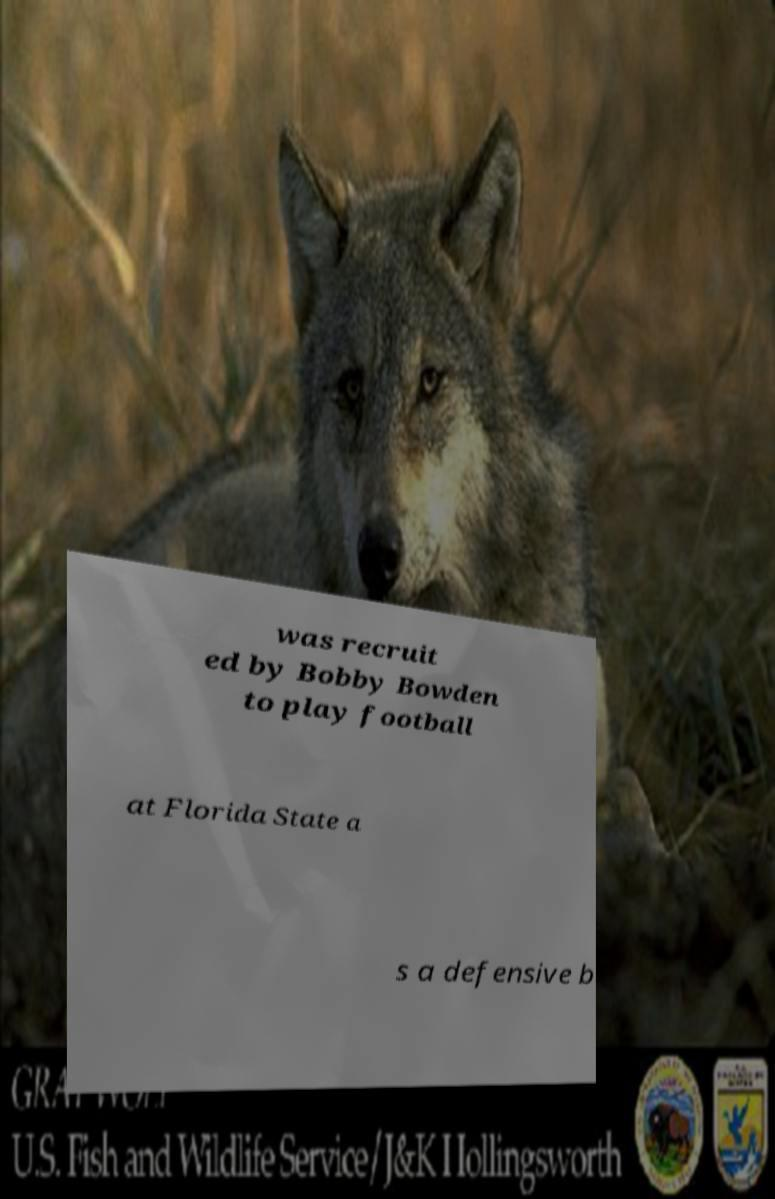Could you extract and type out the text from this image? was recruit ed by Bobby Bowden to play football at Florida State a s a defensive b 